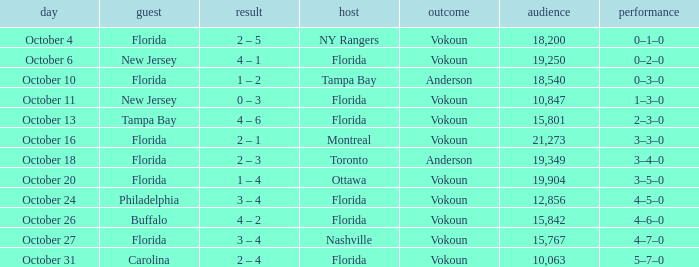What was the score on October 13? 4 – 6. 